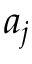Convert formula to latex. <formula><loc_0><loc_0><loc_500><loc_500>a _ { j }</formula> 